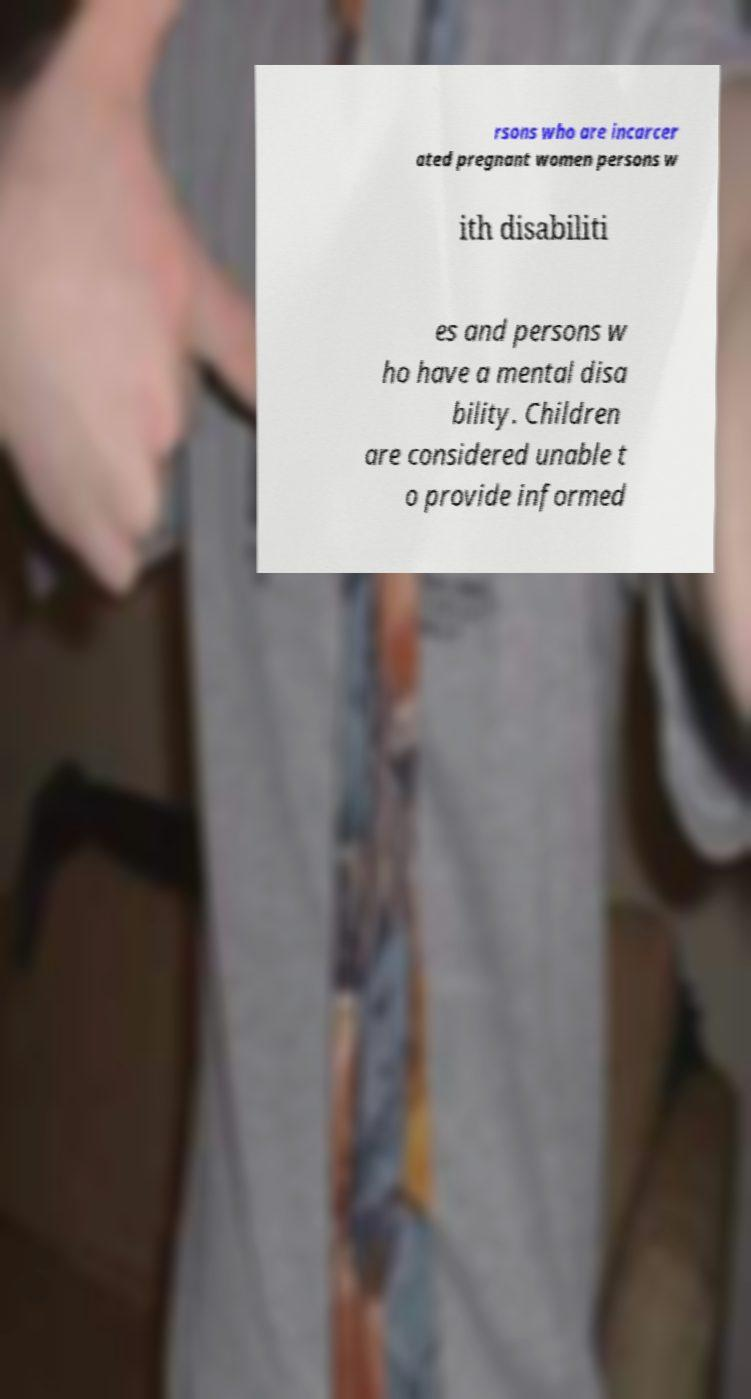Can you accurately transcribe the text from the provided image for me? rsons who are incarcer ated pregnant women persons w ith disabiliti es and persons w ho have a mental disa bility. Children are considered unable t o provide informed 